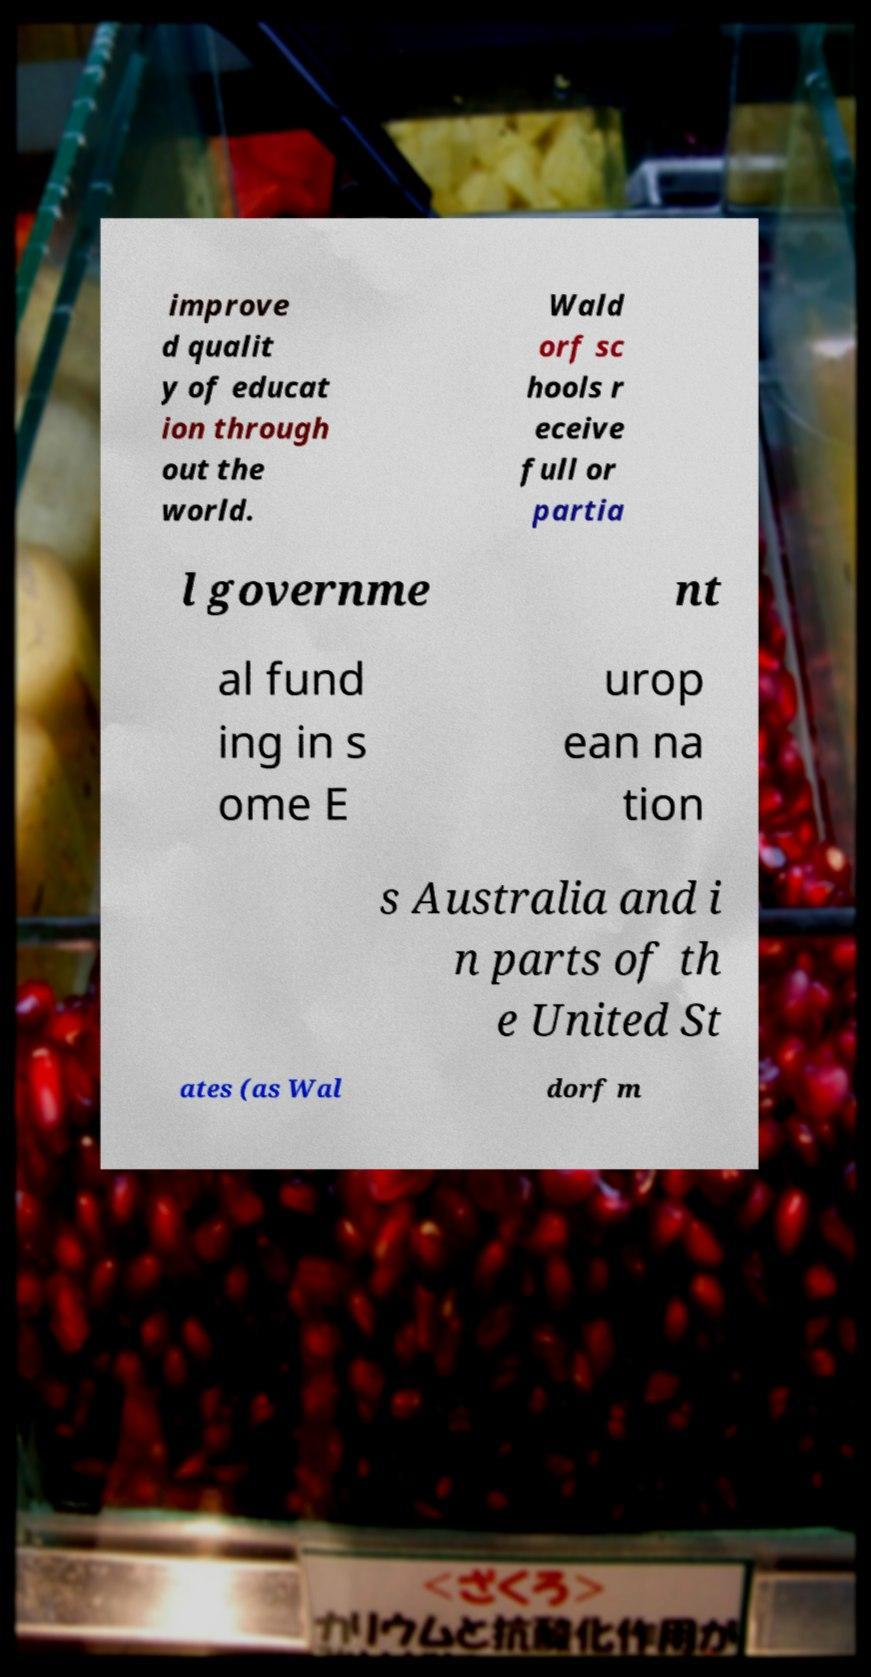Please identify and transcribe the text found in this image. improve d qualit y of educat ion through out the world. Wald orf sc hools r eceive full or partia l governme nt al fund ing in s ome E urop ean na tion s Australia and i n parts of th e United St ates (as Wal dorf m 